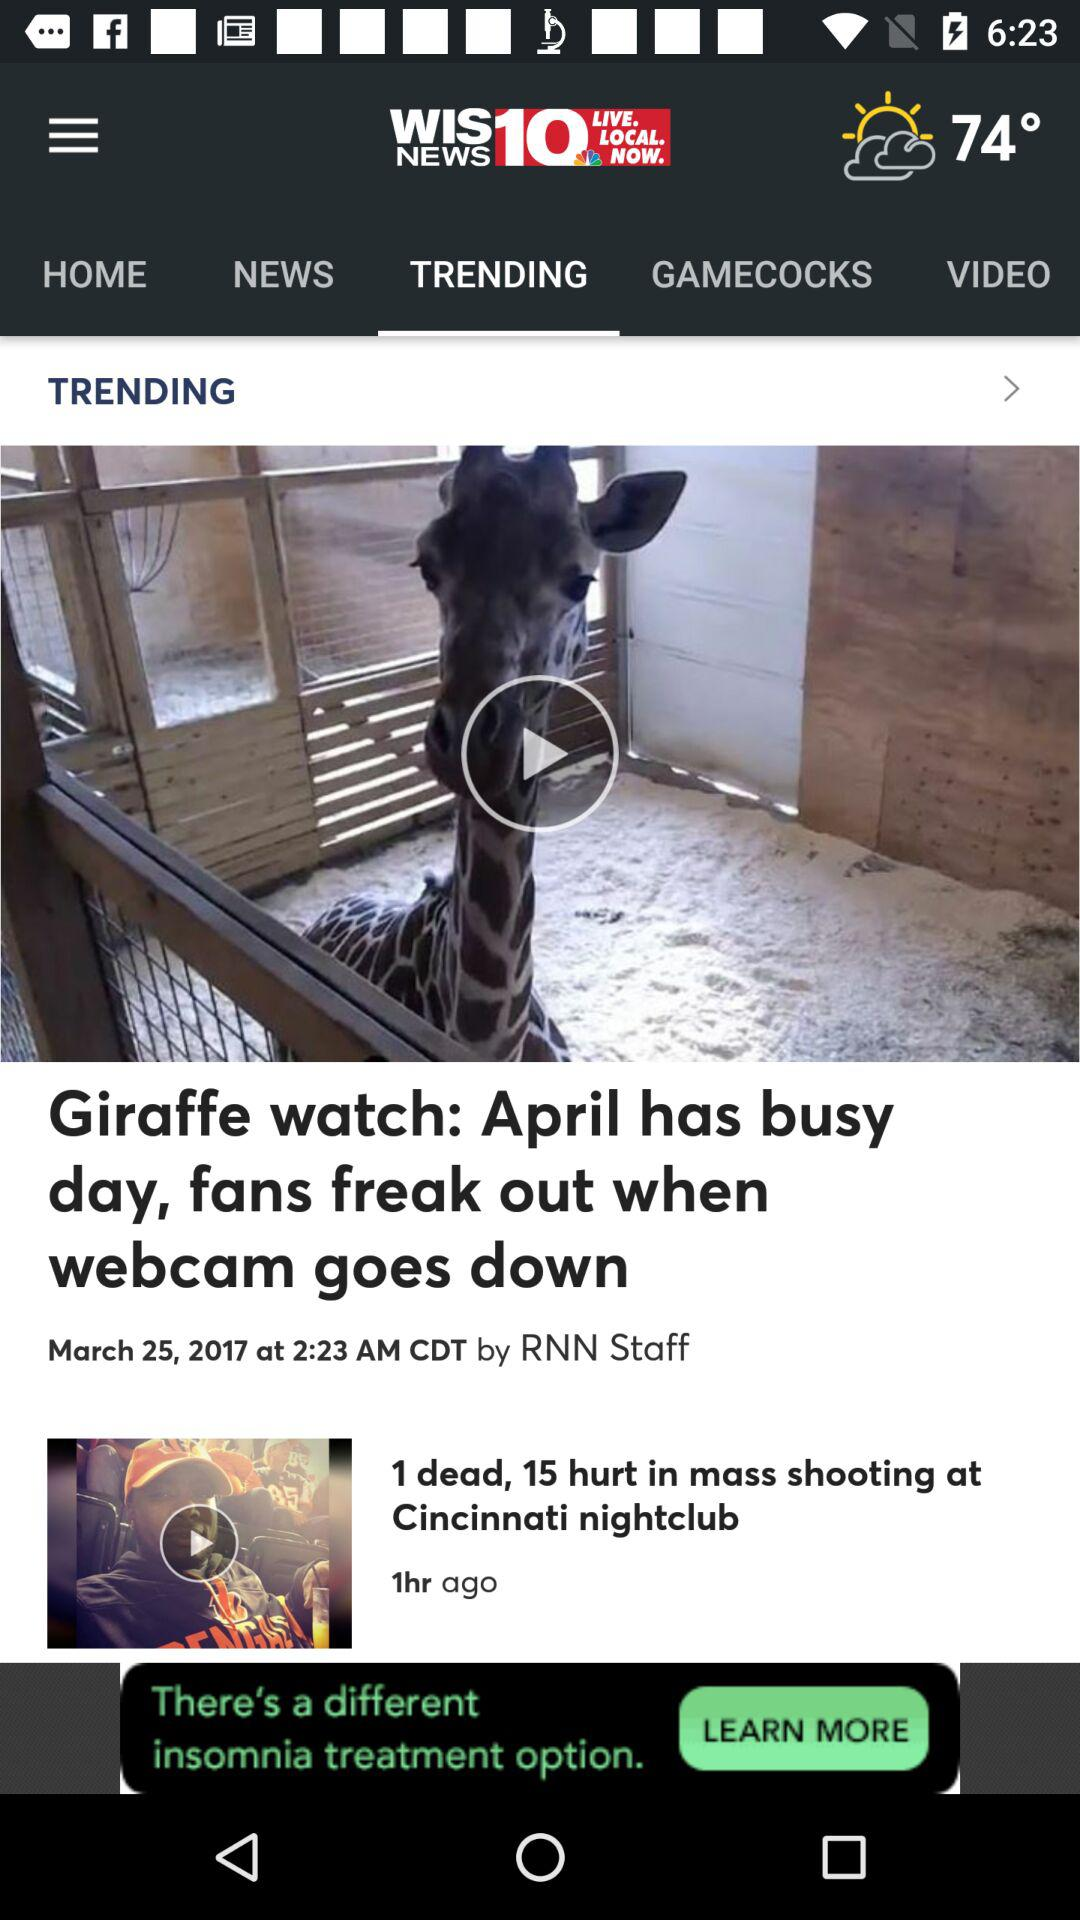When was the "1 dead, 15 hurt in mass shooting at Cincinnati nightclub" posted? It was posted 1 hour ago. 